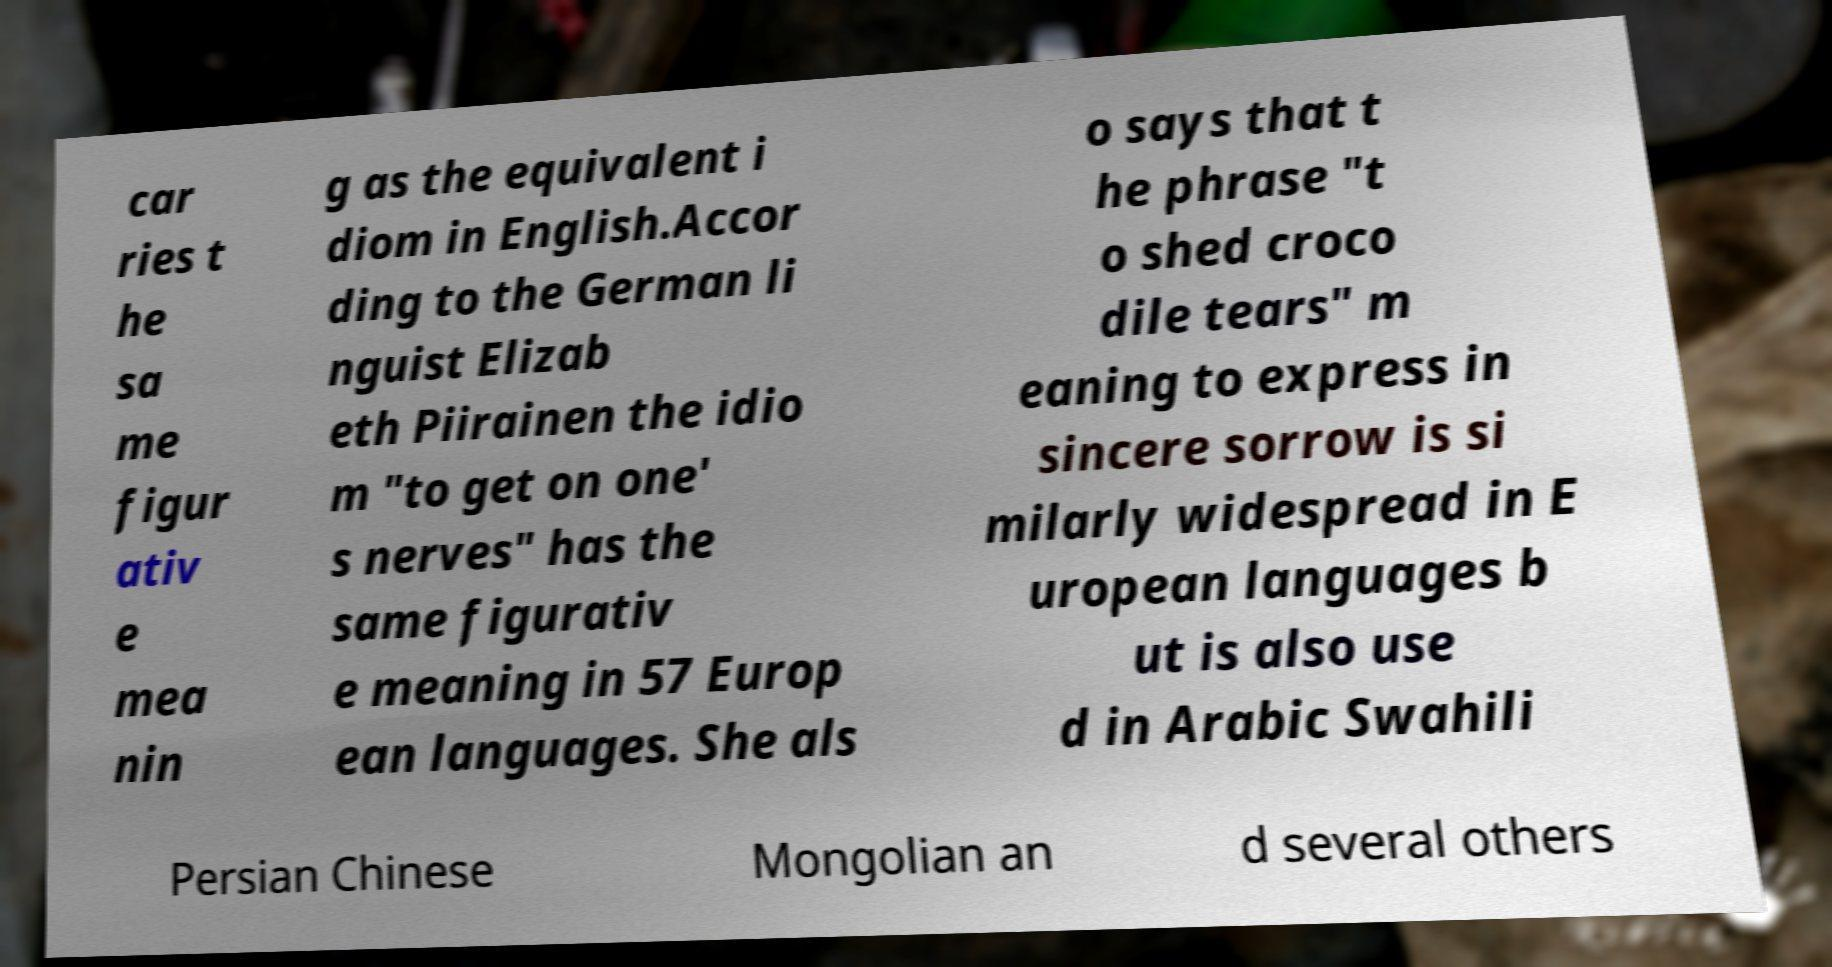Can you read and provide the text displayed in the image?This photo seems to have some interesting text. Can you extract and type it out for me? car ries t he sa me figur ativ e mea nin g as the equivalent i diom in English.Accor ding to the German li nguist Elizab eth Piirainen the idio m "to get on one' s nerves" has the same figurativ e meaning in 57 Europ ean languages. She als o says that t he phrase "t o shed croco dile tears" m eaning to express in sincere sorrow is si milarly widespread in E uropean languages b ut is also use d in Arabic Swahili Persian Chinese Mongolian an d several others 